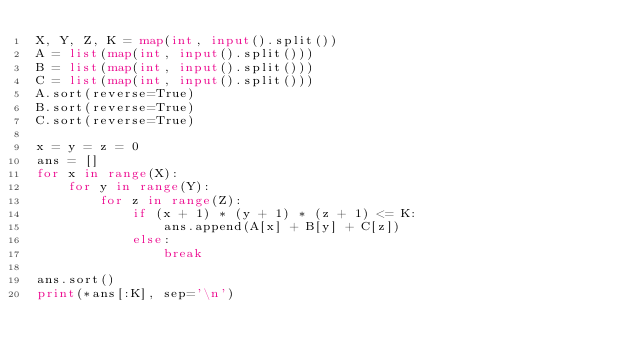<code> <loc_0><loc_0><loc_500><loc_500><_Python_>X, Y, Z, K = map(int, input().split())
A = list(map(int, input().split()))
B = list(map(int, input().split()))
C = list(map(int, input().split()))
A.sort(reverse=True)
B.sort(reverse=True)
C.sort(reverse=True)

x = y = z = 0
ans = []
for x in range(X):
    for y in range(Y):
        for z in range(Z):
            if (x + 1) * (y + 1) * (z + 1) <= K:
                ans.append(A[x] + B[y] + C[z])
            else:
                break

ans.sort()
print(*ans[:K], sep='\n')
</code> 